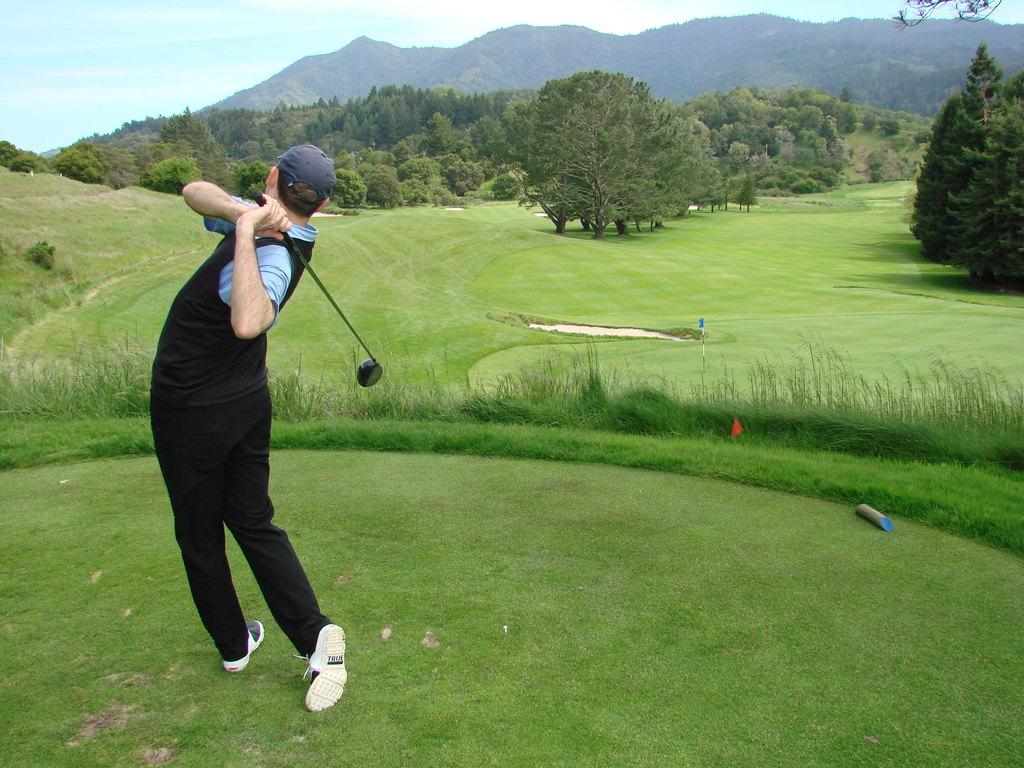What is the main subject of the image? There is a person standing in the image. Can you describe the person's attire? The person is wearing clothes, a cap, and shoes. What object can be seen in the person's hand? There is a golf bat in the image. What type of terrain is visible in the image? There is grass, trees, and a mountain in the image. What part of the natural environment is visible in the image? The sky is visible in the image. What type of glue is being used to hold the structure together in the image? There is no structure or glue present in the image; it features a person standing with a golf bat, grass, trees, a mountain, and the sky. 